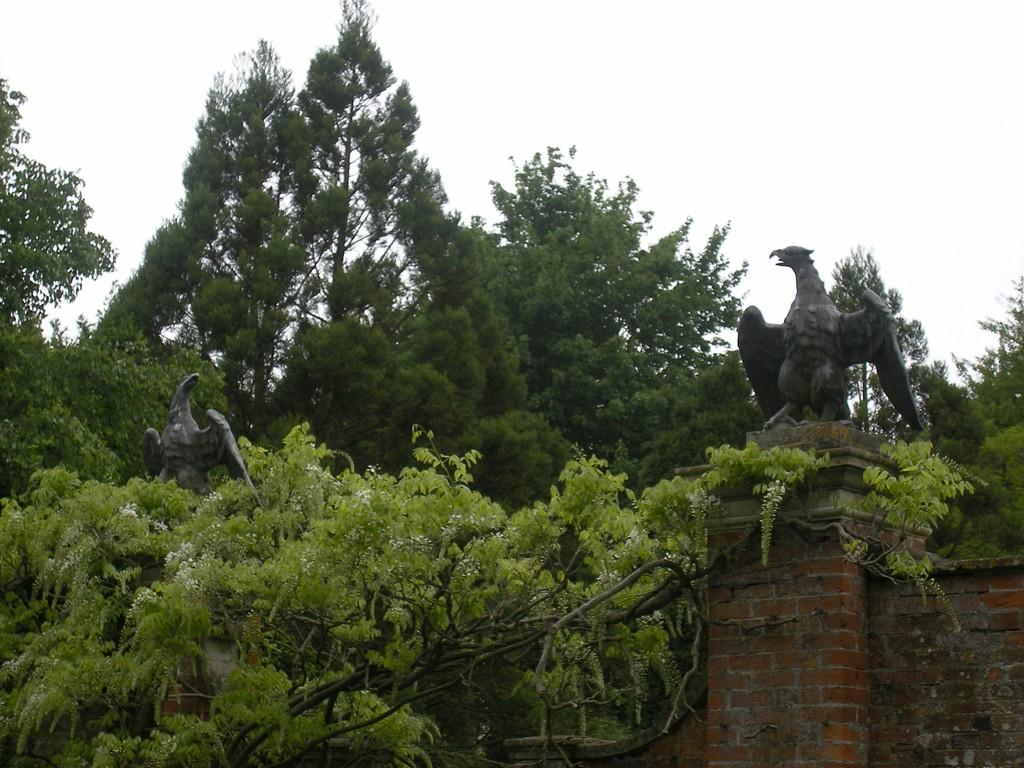What type of vegetation can be seen in the image? There are trees in the image. What is located on the right side of the image? There is a statue of a bird on the right side of the image. What can be seen in the background of the image? The sky is visible in the background of the image. What language is the statue of the bird speaking in the image? The statue of the bird is not speaking, and therefore, there is no language involved. What type of work is the statue of the bird doing in the image? The statue of the bird is not performing any work, as it is a stationary object. 